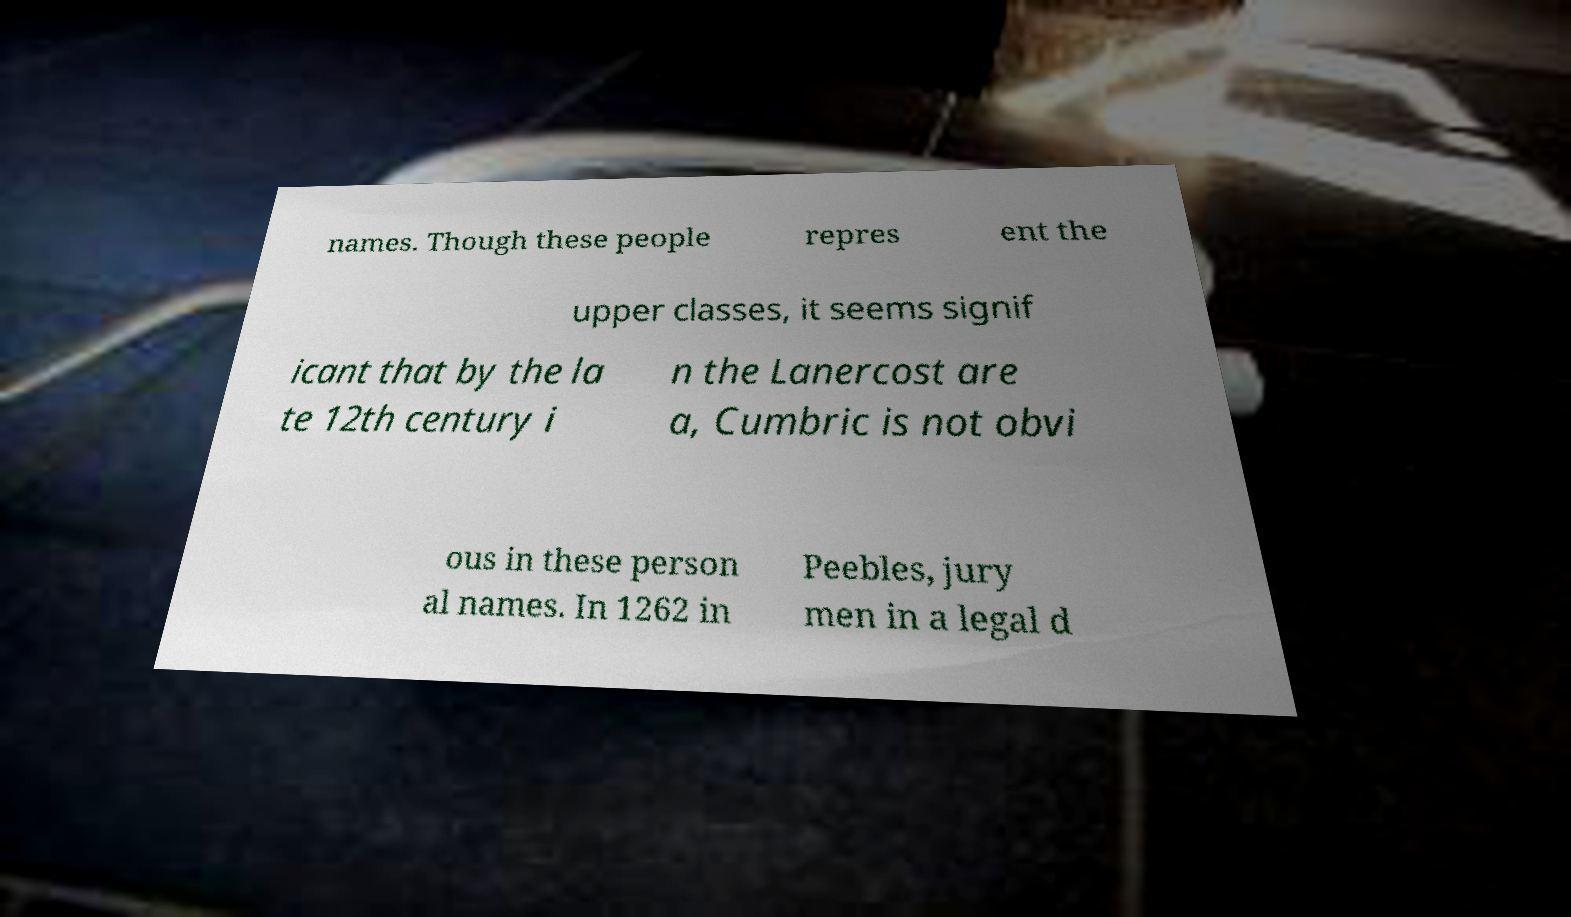I need the written content from this picture converted into text. Can you do that? names. Though these people repres ent the upper classes, it seems signif icant that by the la te 12th century i n the Lanercost are a, Cumbric is not obvi ous in these person al names. In 1262 in Peebles, jury men in a legal d 